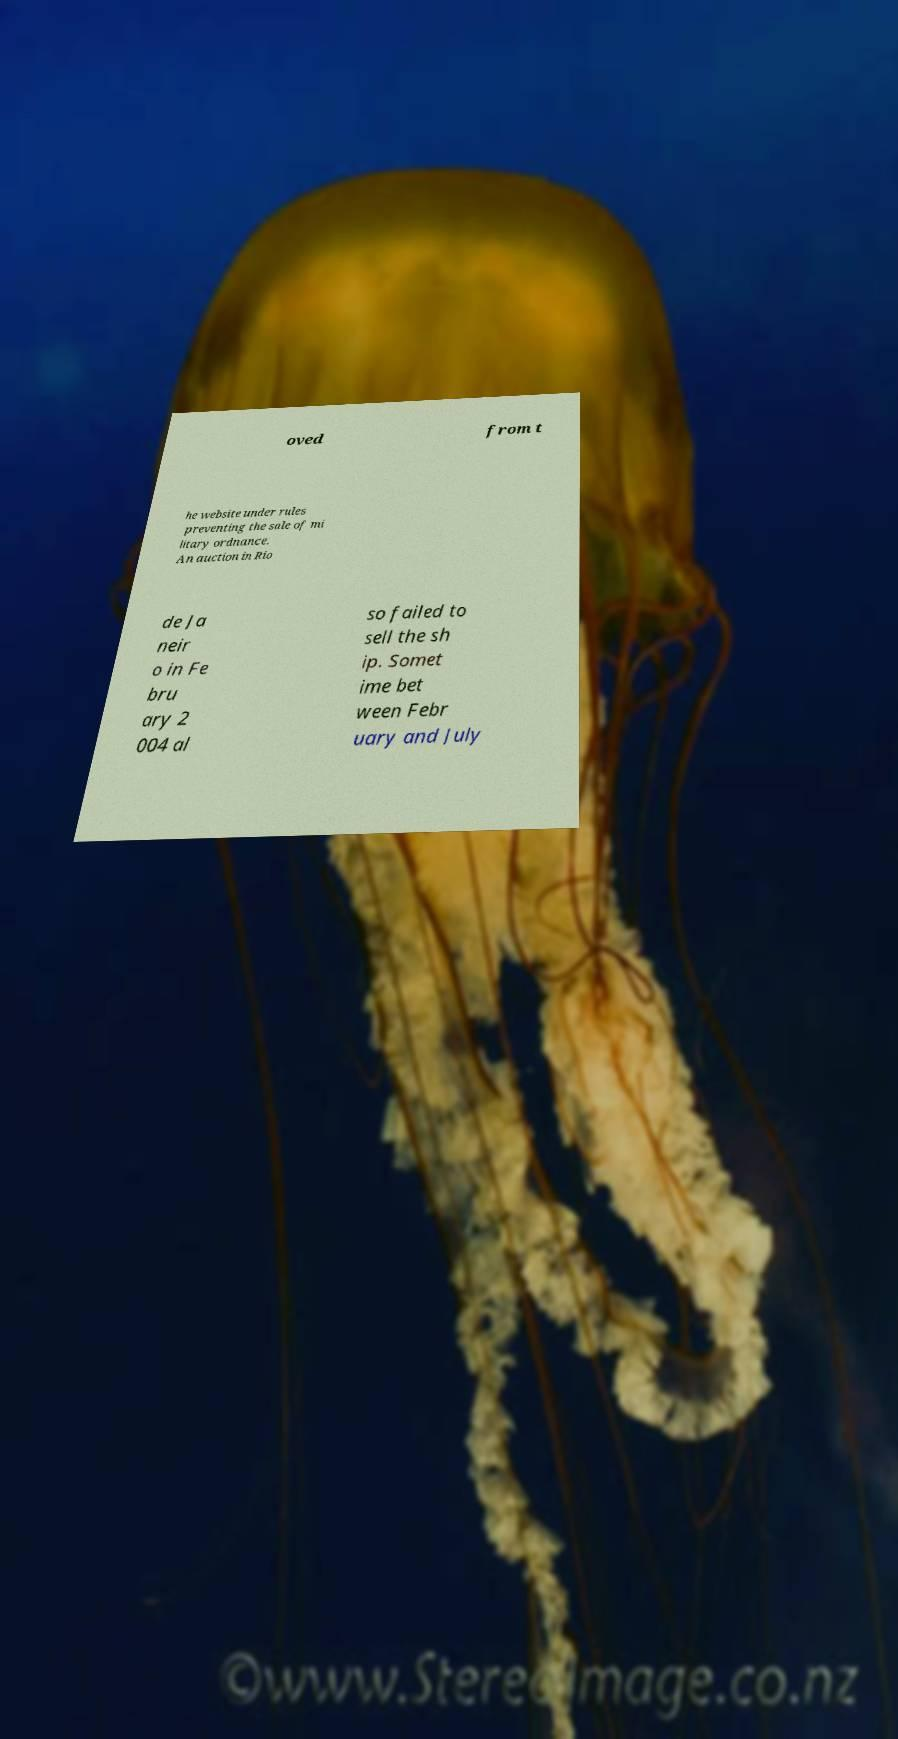Please identify and transcribe the text found in this image. oved from t he website under rules preventing the sale of mi litary ordnance. An auction in Rio de Ja neir o in Fe bru ary 2 004 al so failed to sell the sh ip. Somet ime bet ween Febr uary and July 